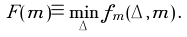<formula> <loc_0><loc_0><loc_500><loc_500>F ( m ) \equiv \min _ { \Delta } f _ { m } ( \Delta , m ) \, .</formula> 